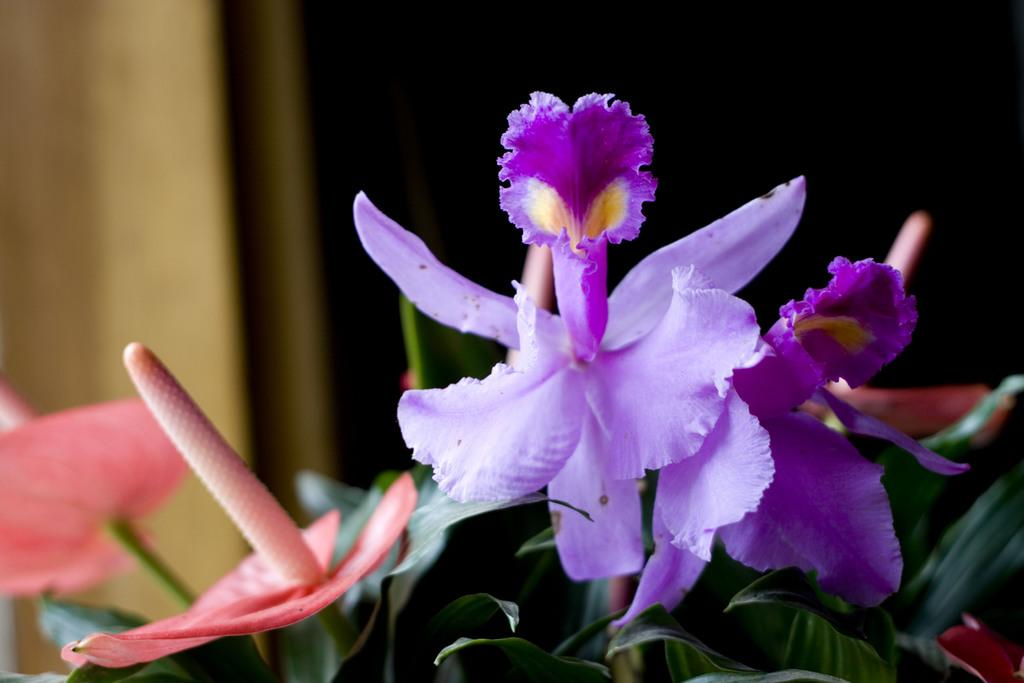What type of flower is located in the front of the image? There is a purple flower in the front of the image. What color is the flower next to the purple flower? There is a red flower beside the purple flower. What else can be seen in the image besides flowers? Leaves are visible in the image. How would you describe the overall lighting or color of the background in the image? The background of the image is dark. What type of fork is used to spread the jam on the red flower in the image? There is no fork or jam present in the image; it features flowers and leaves. 